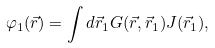Convert formula to latex. <formula><loc_0><loc_0><loc_500><loc_500>\varphi _ { 1 } ( \vec { r } ) = \int d \vec { r } _ { 1 } G ( \vec { r } , \vec { r } _ { 1 } ) J ( \vec { r } _ { 1 } ) ,</formula> 